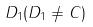Convert formula to latex. <formula><loc_0><loc_0><loc_500><loc_500>D _ { 1 } ( D _ { 1 } \ne C )</formula> 